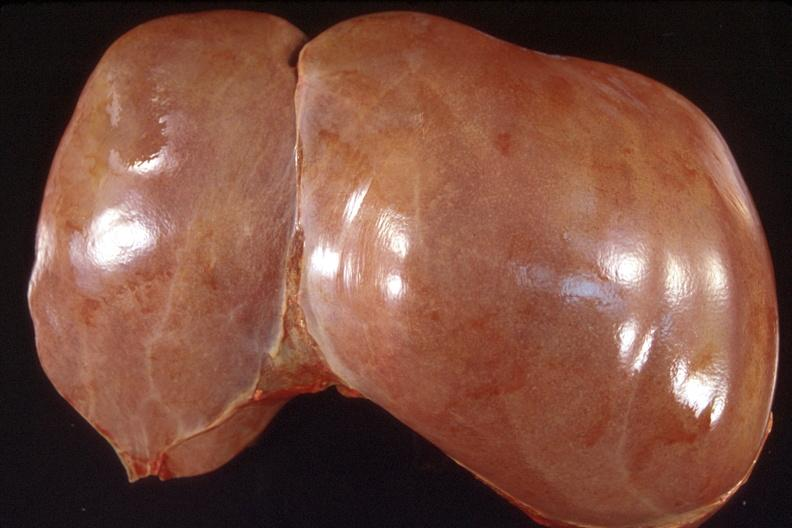does this image show liver, normal?
Answer the question using a single word or phrase. Yes 